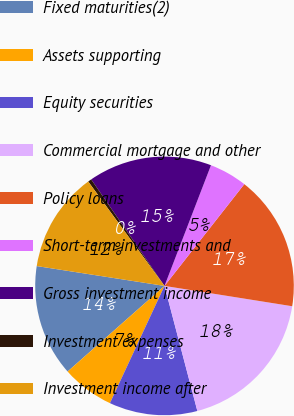Convert chart. <chart><loc_0><loc_0><loc_500><loc_500><pie_chart><fcel>Fixed maturities(2)<fcel>Assets supporting<fcel>Equity securities<fcel>Commercial mortgage and other<fcel>Policy loans<fcel>Short-term investments and<fcel>Gross investment income<fcel>Investment expenses<fcel>Investment income after<nl><fcel>13.97%<fcel>6.55%<fcel>11.02%<fcel>18.4%<fcel>16.93%<fcel>4.73%<fcel>15.45%<fcel>0.45%<fcel>12.5%<nl></chart> 